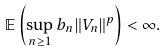Convert formula to latex. <formula><loc_0><loc_0><loc_500><loc_500>\mathbb { E } \left ( \sup _ { n \geq 1 } b _ { n } \| V _ { n } \| ^ { p } \right ) < \infty .</formula> 